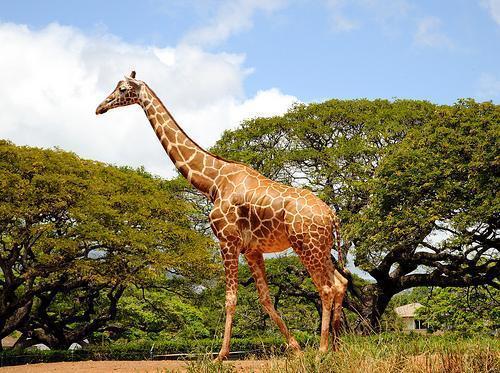How many animals?
Give a very brief answer. 1. How many building are there?
Give a very brief answer. 2. 